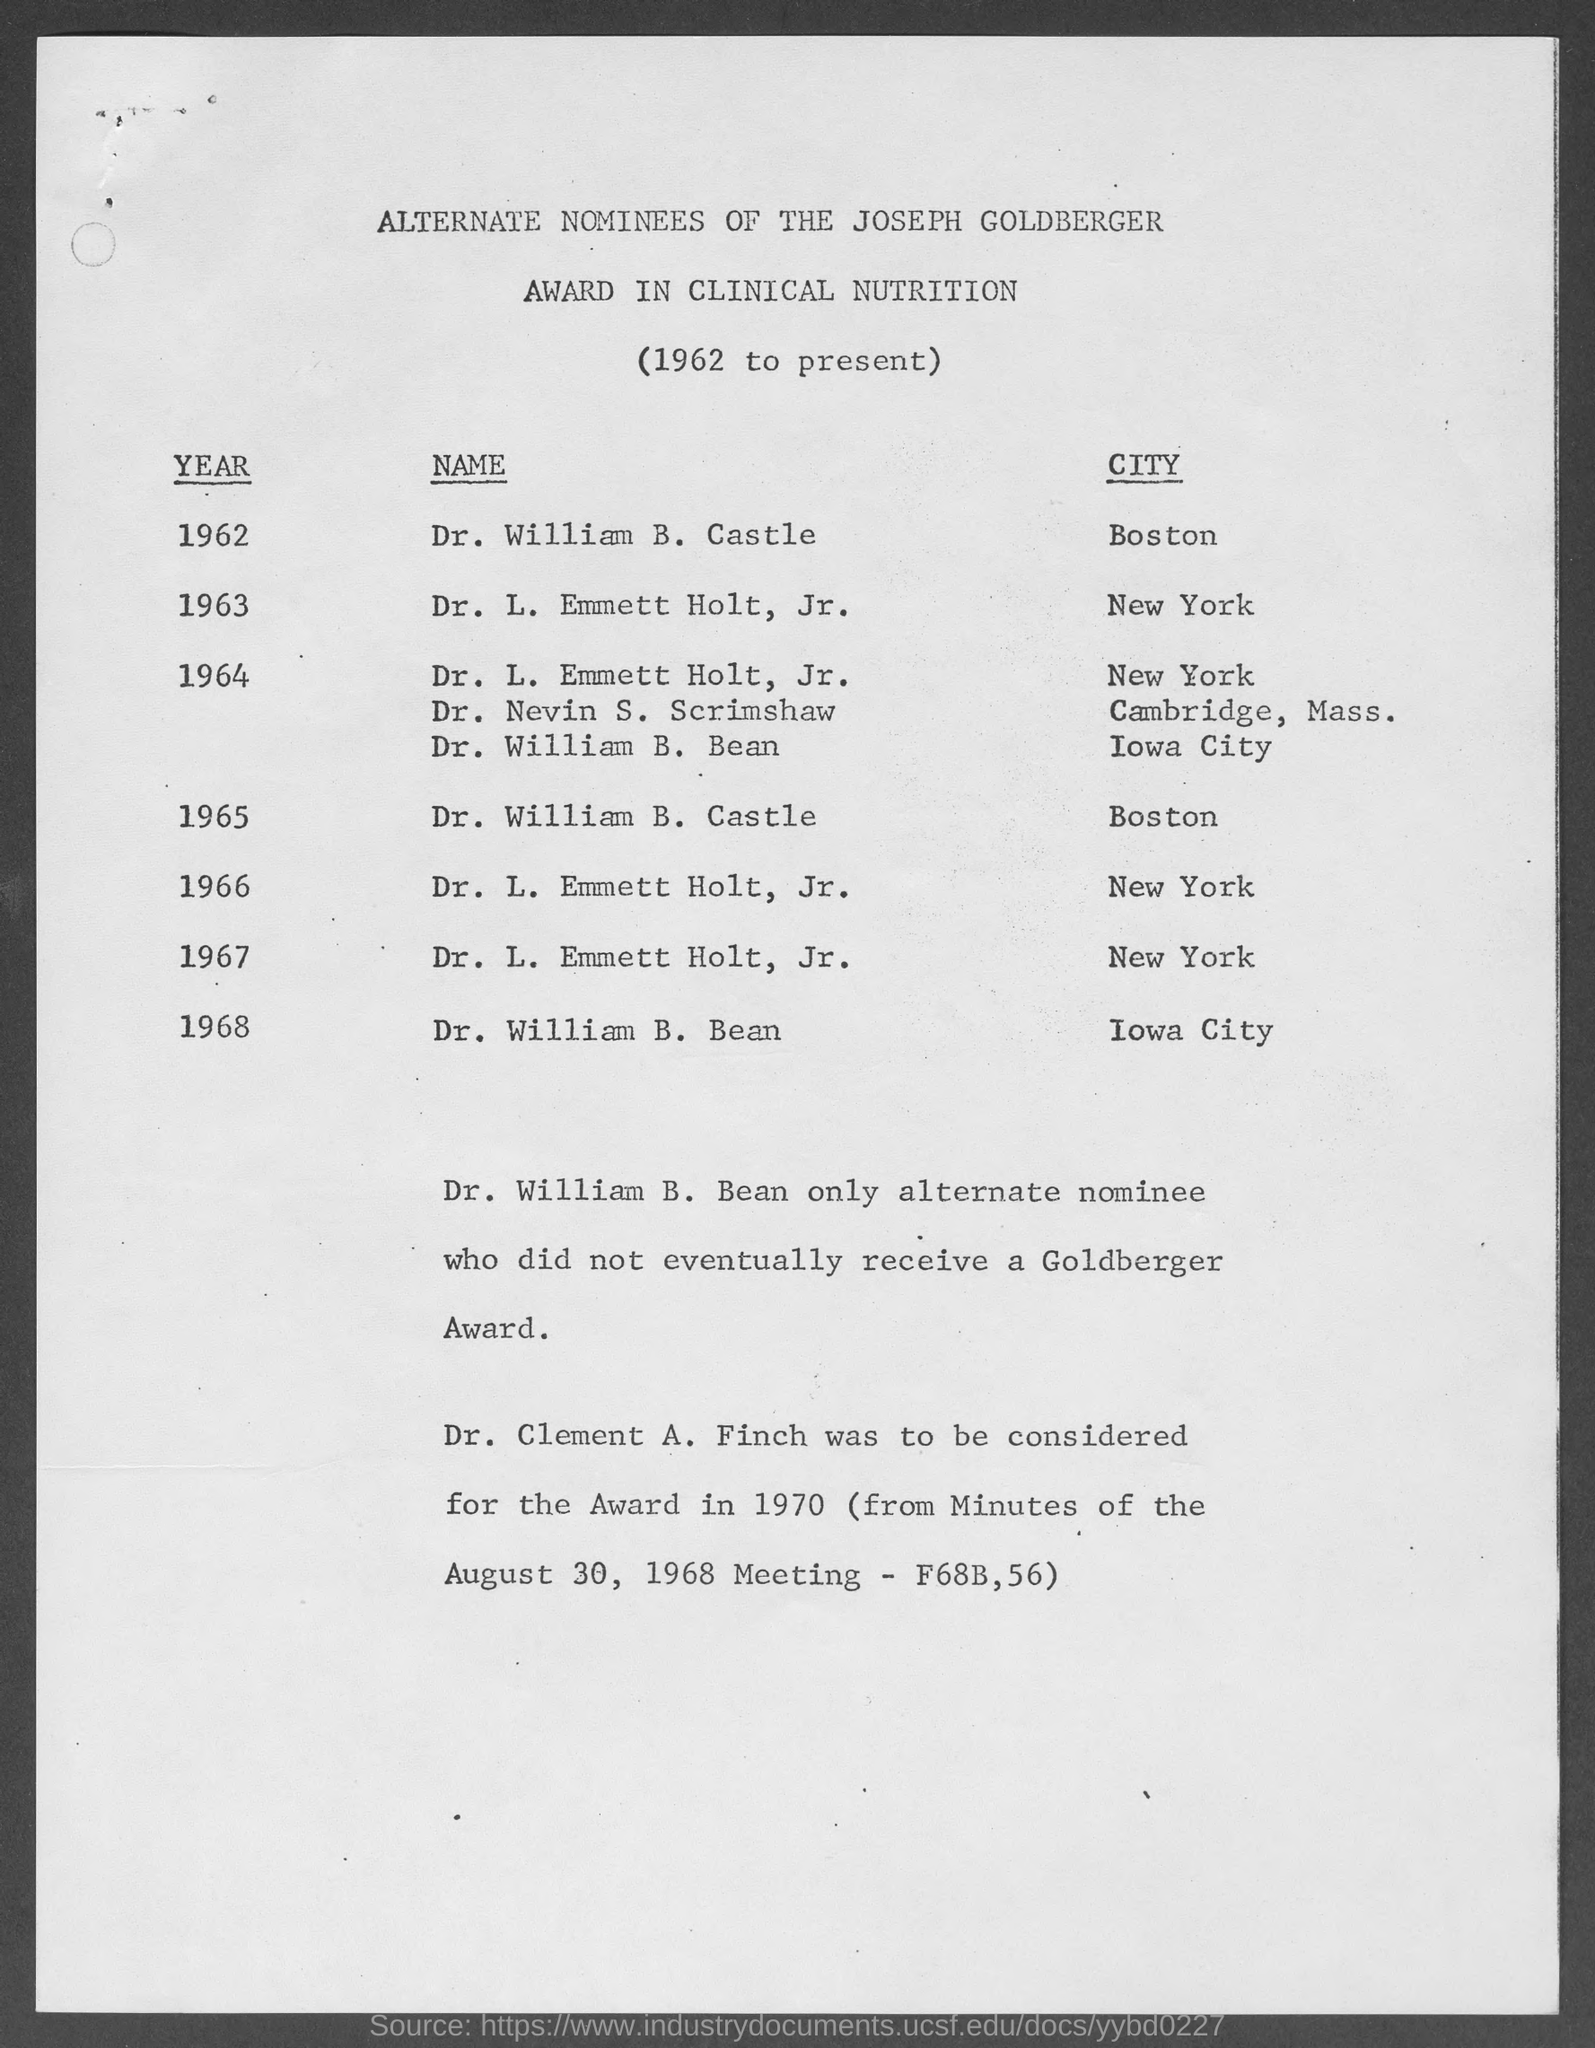Indicate a few pertinent items in this graphic. It was determined at the August 30, 1968 meeting that Dr. Clement A. Finch was to be considered for the award in 1970, as noted in the minutes of the meeting (F68B,56). Dr. William B. Bean was the only alternative who did not eventually receive a Goldberger Award. The alternate nominee for the Joseph Goldberger Award in Clinical Nutrition for the year 1968 in Iowa City was Dr. William B. Bean. In the year 1963, the Joseph Goldberger Award in Clinical Nutrition had an alternate nominee, and that person was Dr. L. Emmett Holt, Jr. In the year 1962, in Boston, Dr. William B. Castle was the alternate nominee for the Joseph Goldberger Award in Clinical Nutrition. 